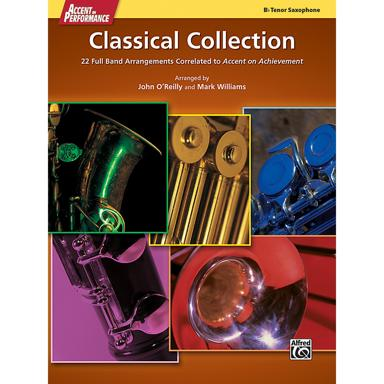What is unique about this classical collection? The 'Tenor Saxophone Classical Collection' stands out for its comprehensive set of 22 full band arrangements. These pieces are carefully selected to complement the 'Accent on Achievement' curriculum by John O'Reilly and Mark Williams, providing a coherent progression for music students and instructors. 